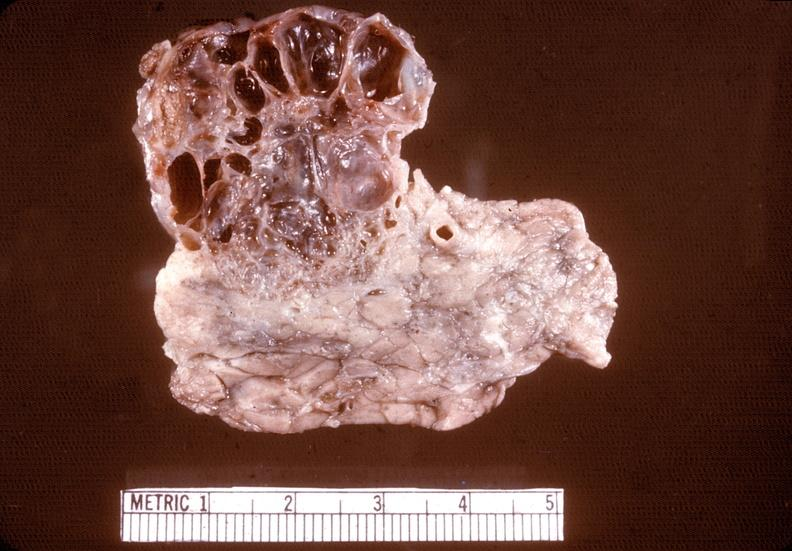s numerous atypical cells around splenic arteriole man present?
Answer the question using a single word or phrase. No 